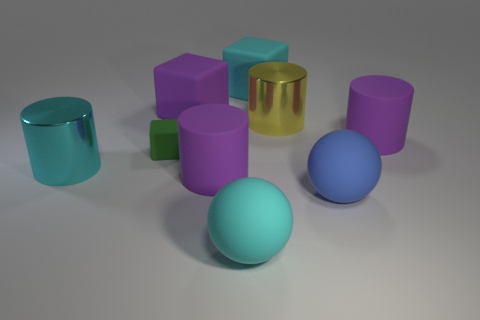Subtract all blue cylinders. Subtract all purple spheres. How many cylinders are left? 4 Subtract all yellow spheres. How many yellow cylinders are left? 1 Add 8 small reds. How many large objects exist? 0 Subtract all cylinders. Subtract all blue objects. How many objects are left? 4 Add 2 matte objects. How many matte objects are left? 9 Add 1 big brown matte objects. How many big brown matte objects exist? 1 Add 1 yellow metal cylinders. How many objects exist? 10 Subtract all green blocks. How many blocks are left? 2 Subtract all cyan shiny cylinders. How many cylinders are left? 3 Subtract 1 yellow cylinders. How many objects are left? 8 